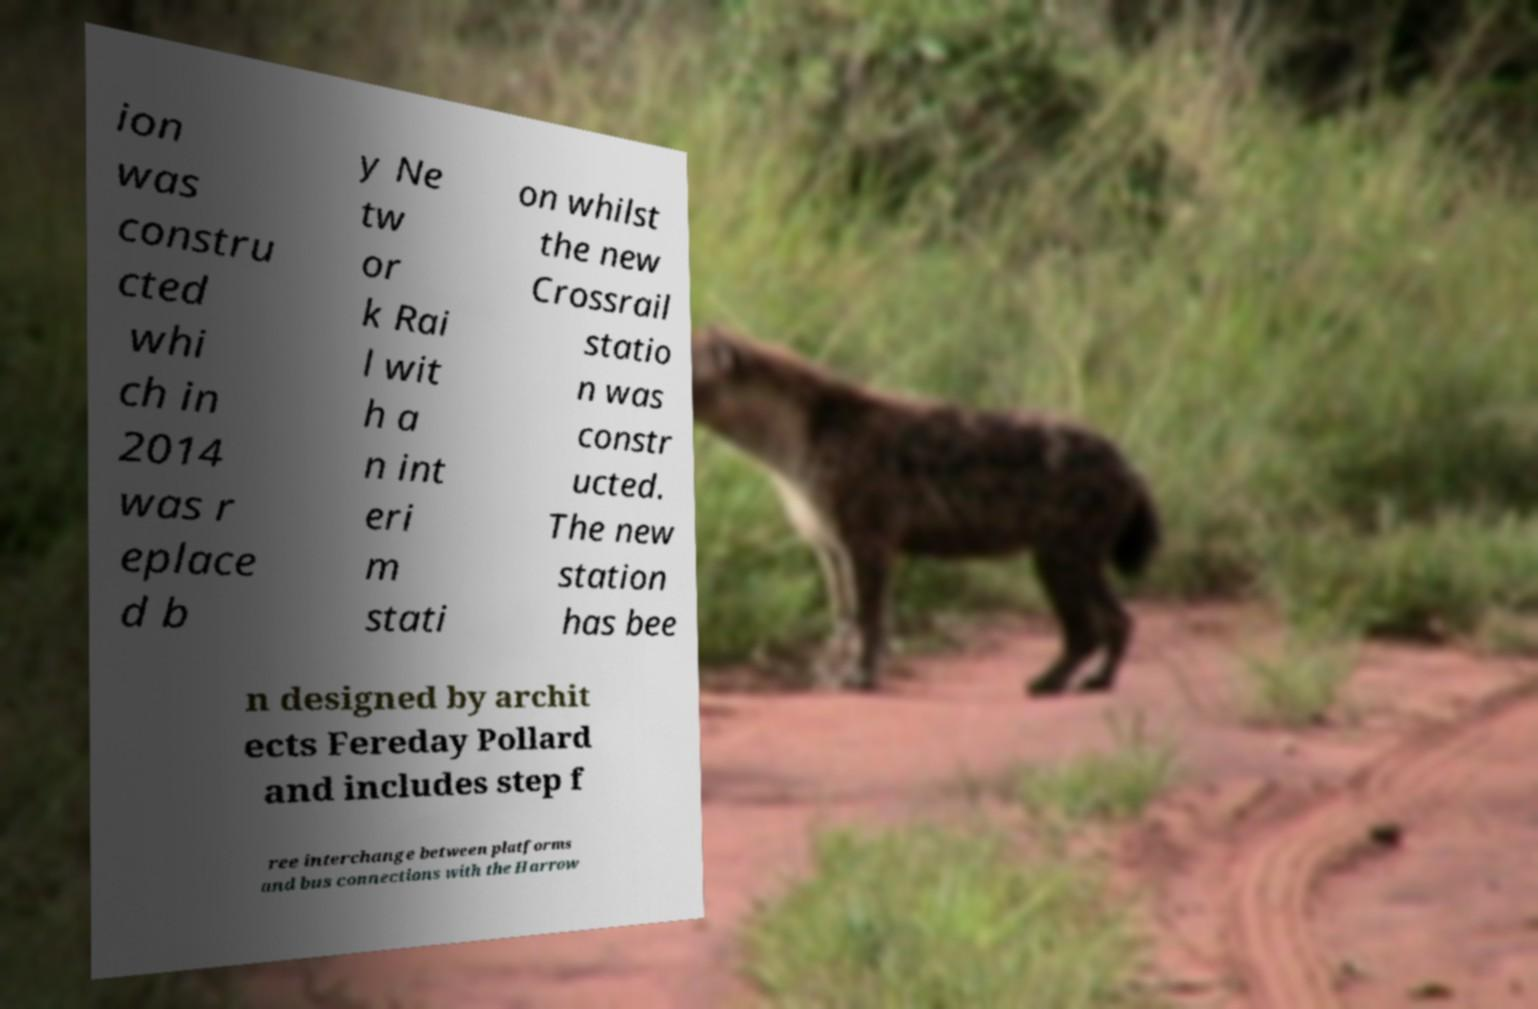What messages or text are displayed in this image? I need them in a readable, typed format. ion was constru cted whi ch in 2014 was r eplace d b y Ne tw or k Rai l wit h a n int eri m stati on whilst the new Crossrail statio n was constr ucted. The new station has bee n designed by archit ects Fereday Pollard and includes step f ree interchange between platforms and bus connections with the Harrow 